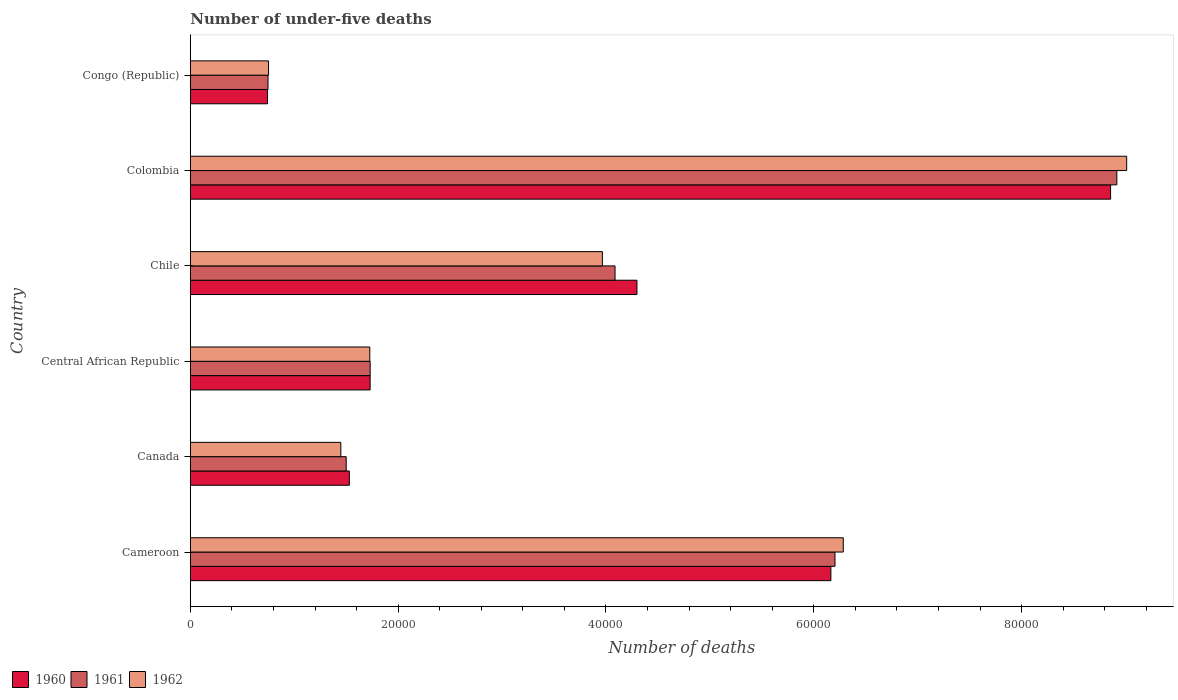How many bars are there on the 5th tick from the top?
Keep it short and to the point. 3. How many bars are there on the 3rd tick from the bottom?
Keep it short and to the point. 3. What is the label of the 4th group of bars from the top?
Ensure brevity in your answer.  Central African Republic. What is the number of under-five deaths in 1962 in Congo (Republic)?
Your response must be concise. 7530. Across all countries, what is the maximum number of under-five deaths in 1962?
Your answer should be compact. 9.01e+04. Across all countries, what is the minimum number of under-five deaths in 1961?
Give a very brief answer. 7480. In which country was the number of under-five deaths in 1960 minimum?
Ensure brevity in your answer.  Congo (Republic). What is the total number of under-five deaths in 1961 in the graph?
Your response must be concise. 2.32e+05. What is the difference between the number of under-five deaths in 1962 in Canada and that in Chile?
Offer a very short reply. -2.52e+04. What is the difference between the number of under-five deaths in 1961 in Congo (Republic) and the number of under-five deaths in 1962 in Chile?
Keep it short and to the point. -3.22e+04. What is the average number of under-five deaths in 1960 per country?
Keep it short and to the point. 3.89e+04. In how many countries, is the number of under-five deaths in 1961 greater than 40000 ?
Keep it short and to the point. 3. What is the ratio of the number of under-five deaths in 1960 in Canada to that in Central African Republic?
Provide a succinct answer. 0.88. Is the number of under-five deaths in 1960 in Central African Republic less than that in Colombia?
Your response must be concise. Yes. What is the difference between the highest and the second highest number of under-five deaths in 1962?
Your answer should be compact. 2.73e+04. What is the difference between the highest and the lowest number of under-five deaths in 1960?
Keep it short and to the point. 8.11e+04. In how many countries, is the number of under-five deaths in 1962 greater than the average number of under-five deaths in 1962 taken over all countries?
Make the answer very short. 3. What does the 2nd bar from the top in Canada represents?
Give a very brief answer. 1961. What does the 1st bar from the bottom in Cameroon represents?
Provide a short and direct response. 1960. Are all the bars in the graph horizontal?
Your answer should be very brief. Yes. How many countries are there in the graph?
Keep it short and to the point. 6. What is the difference between two consecutive major ticks on the X-axis?
Your answer should be compact. 2.00e+04. Are the values on the major ticks of X-axis written in scientific E-notation?
Offer a terse response. No. Does the graph contain any zero values?
Offer a very short reply. No. Where does the legend appear in the graph?
Provide a succinct answer. Bottom left. What is the title of the graph?
Provide a succinct answer. Number of under-five deaths. Does "1991" appear as one of the legend labels in the graph?
Offer a very short reply. No. What is the label or title of the X-axis?
Provide a succinct answer. Number of deaths. What is the label or title of the Y-axis?
Ensure brevity in your answer.  Country. What is the Number of deaths in 1960 in Cameroon?
Make the answer very short. 6.16e+04. What is the Number of deaths of 1961 in Cameroon?
Offer a terse response. 6.20e+04. What is the Number of deaths of 1962 in Cameroon?
Your response must be concise. 6.28e+04. What is the Number of deaths in 1960 in Canada?
Make the answer very short. 1.53e+04. What is the Number of deaths of 1961 in Canada?
Give a very brief answer. 1.50e+04. What is the Number of deaths in 1962 in Canada?
Your answer should be very brief. 1.45e+04. What is the Number of deaths in 1960 in Central African Republic?
Provide a short and direct response. 1.73e+04. What is the Number of deaths of 1961 in Central African Republic?
Offer a terse response. 1.73e+04. What is the Number of deaths in 1962 in Central African Republic?
Your answer should be compact. 1.73e+04. What is the Number of deaths of 1960 in Chile?
Give a very brief answer. 4.30e+04. What is the Number of deaths of 1961 in Chile?
Offer a terse response. 4.09e+04. What is the Number of deaths in 1962 in Chile?
Provide a short and direct response. 3.97e+04. What is the Number of deaths in 1960 in Colombia?
Offer a terse response. 8.86e+04. What is the Number of deaths in 1961 in Colombia?
Make the answer very short. 8.92e+04. What is the Number of deaths of 1962 in Colombia?
Offer a terse response. 9.01e+04. What is the Number of deaths of 1960 in Congo (Republic)?
Your answer should be very brief. 7431. What is the Number of deaths of 1961 in Congo (Republic)?
Offer a very short reply. 7480. What is the Number of deaths of 1962 in Congo (Republic)?
Keep it short and to the point. 7530. Across all countries, what is the maximum Number of deaths in 1960?
Provide a short and direct response. 8.86e+04. Across all countries, what is the maximum Number of deaths in 1961?
Make the answer very short. 8.92e+04. Across all countries, what is the maximum Number of deaths of 1962?
Your answer should be compact. 9.01e+04. Across all countries, what is the minimum Number of deaths in 1960?
Offer a terse response. 7431. Across all countries, what is the minimum Number of deaths in 1961?
Your response must be concise. 7480. Across all countries, what is the minimum Number of deaths of 1962?
Your answer should be compact. 7530. What is the total Number of deaths in 1960 in the graph?
Give a very brief answer. 2.33e+05. What is the total Number of deaths of 1961 in the graph?
Provide a short and direct response. 2.32e+05. What is the total Number of deaths in 1962 in the graph?
Make the answer very short. 2.32e+05. What is the difference between the Number of deaths in 1960 in Cameroon and that in Canada?
Offer a terse response. 4.63e+04. What is the difference between the Number of deaths in 1961 in Cameroon and that in Canada?
Your response must be concise. 4.70e+04. What is the difference between the Number of deaths in 1962 in Cameroon and that in Canada?
Your answer should be compact. 4.83e+04. What is the difference between the Number of deaths in 1960 in Cameroon and that in Central African Republic?
Offer a terse response. 4.43e+04. What is the difference between the Number of deaths of 1961 in Cameroon and that in Central African Republic?
Provide a succinct answer. 4.47e+04. What is the difference between the Number of deaths in 1962 in Cameroon and that in Central African Republic?
Your answer should be very brief. 4.56e+04. What is the difference between the Number of deaths in 1960 in Cameroon and that in Chile?
Your response must be concise. 1.87e+04. What is the difference between the Number of deaths of 1961 in Cameroon and that in Chile?
Your answer should be compact. 2.12e+04. What is the difference between the Number of deaths of 1962 in Cameroon and that in Chile?
Your answer should be very brief. 2.32e+04. What is the difference between the Number of deaths in 1960 in Cameroon and that in Colombia?
Your response must be concise. -2.69e+04. What is the difference between the Number of deaths in 1961 in Cameroon and that in Colombia?
Give a very brief answer. -2.71e+04. What is the difference between the Number of deaths in 1962 in Cameroon and that in Colombia?
Your answer should be compact. -2.73e+04. What is the difference between the Number of deaths in 1960 in Cameroon and that in Congo (Republic)?
Provide a short and direct response. 5.42e+04. What is the difference between the Number of deaths of 1961 in Cameroon and that in Congo (Republic)?
Provide a succinct answer. 5.46e+04. What is the difference between the Number of deaths of 1962 in Cameroon and that in Congo (Republic)?
Give a very brief answer. 5.53e+04. What is the difference between the Number of deaths in 1960 in Canada and that in Central African Republic?
Your response must be concise. -2000. What is the difference between the Number of deaths of 1961 in Canada and that in Central African Republic?
Provide a short and direct response. -2304. What is the difference between the Number of deaths in 1962 in Canada and that in Central African Republic?
Give a very brief answer. -2788. What is the difference between the Number of deaths in 1960 in Canada and that in Chile?
Offer a terse response. -2.77e+04. What is the difference between the Number of deaths of 1961 in Canada and that in Chile?
Provide a succinct answer. -2.59e+04. What is the difference between the Number of deaths in 1962 in Canada and that in Chile?
Offer a very short reply. -2.52e+04. What is the difference between the Number of deaths in 1960 in Canada and that in Colombia?
Offer a very short reply. -7.33e+04. What is the difference between the Number of deaths in 1961 in Canada and that in Colombia?
Your answer should be very brief. -7.42e+04. What is the difference between the Number of deaths in 1962 in Canada and that in Colombia?
Ensure brevity in your answer.  -7.56e+04. What is the difference between the Number of deaths in 1960 in Canada and that in Congo (Republic)?
Offer a terse response. 7874. What is the difference between the Number of deaths of 1961 in Canada and that in Congo (Republic)?
Your response must be concise. 7522. What is the difference between the Number of deaths in 1962 in Canada and that in Congo (Republic)?
Offer a very short reply. 6955. What is the difference between the Number of deaths of 1960 in Central African Republic and that in Chile?
Your answer should be very brief. -2.57e+04. What is the difference between the Number of deaths of 1961 in Central African Republic and that in Chile?
Keep it short and to the point. -2.36e+04. What is the difference between the Number of deaths in 1962 in Central African Republic and that in Chile?
Make the answer very short. -2.24e+04. What is the difference between the Number of deaths of 1960 in Central African Republic and that in Colombia?
Give a very brief answer. -7.13e+04. What is the difference between the Number of deaths of 1961 in Central African Republic and that in Colombia?
Keep it short and to the point. -7.18e+04. What is the difference between the Number of deaths in 1962 in Central African Republic and that in Colombia?
Your answer should be very brief. -7.28e+04. What is the difference between the Number of deaths in 1960 in Central African Republic and that in Congo (Republic)?
Provide a short and direct response. 9874. What is the difference between the Number of deaths in 1961 in Central African Republic and that in Congo (Republic)?
Keep it short and to the point. 9826. What is the difference between the Number of deaths of 1962 in Central African Republic and that in Congo (Republic)?
Offer a terse response. 9743. What is the difference between the Number of deaths in 1960 in Chile and that in Colombia?
Your answer should be very brief. -4.56e+04. What is the difference between the Number of deaths of 1961 in Chile and that in Colombia?
Keep it short and to the point. -4.83e+04. What is the difference between the Number of deaths of 1962 in Chile and that in Colombia?
Provide a succinct answer. -5.04e+04. What is the difference between the Number of deaths of 1960 in Chile and that in Congo (Republic)?
Offer a terse response. 3.55e+04. What is the difference between the Number of deaths of 1961 in Chile and that in Congo (Republic)?
Keep it short and to the point. 3.34e+04. What is the difference between the Number of deaths in 1962 in Chile and that in Congo (Republic)?
Give a very brief answer. 3.21e+04. What is the difference between the Number of deaths of 1960 in Colombia and that in Congo (Republic)?
Provide a succinct answer. 8.11e+04. What is the difference between the Number of deaths of 1961 in Colombia and that in Congo (Republic)?
Offer a terse response. 8.17e+04. What is the difference between the Number of deaths in 1962 in Colombia and that in Congo (Republic)?
Offer a very short reply. 8.26e+04. What is the difference between the Number of deaths of 1960 in Cameroon and the Number of deaths of 1961 in Canada?
Give a very brief answer. 4.66e+04. What is the difference between the Number of deaths in 1960 in Cameroon and the Number of deaths in 1962 in Canada?
Make the answer very short. 4.72e+04. What is the difference between the Number of deaths of 1961 in Cameroon and the Number of deaths of 1962 in Canada?
Ensure brevity in your answer.  4.76e+04. What is the difference between the Number of deaths in 1960 in Cameroon and the Number of deaths in 1961 in Central African Republic?
Offer a terse response. 4.43e+04. What is the difference between the Number of deaths in 1960 in Cameroon and the Number of deaths in 1962 in Central African Republic?
Your answer should be compact. 4.44e+04. What is the difference between the Number of deaths in 1961 in Cameroon and the Number of deaths in 1962 in Central African Republic?
Make the answer very short. 4.48e+04. What is the difference between the Number of deaths of 1960 in Cameroon and the Number of deaths of 1961 in Chile?
Your answer should be very brief. 2.08e+04. What is the difference between the Number of deaths in 1960 in Cameroon and the Number of deaths in 1962 in Chile?
Your answer should be compact. 2.20e+04. What is the difference between the Number of deaths in 1961 in Cameroon and the Number of deaths in 1962 in Chile?
Provide a succinct answer. 2.24e+04. What is the difference between the Number of deaths of 1960 in Cameroon and the Number of deaths of 1961 in Colombia?
Your response must be concise. -2.75e+04. What is the difference between the Number of deaths in 1960 in Cameroon and the Number of deaths in 1962 in Colombia?
Give a very brief answer. -2.85e+04. What is the difference between the Number of deaths of 1961 in Cameroon and the Number of deaths of 1962 in Colombia?
Give a very brief answer. -2.81e+04. What is the difference between the Number of deaths in 1960 in Cameroon and the Number of deaths in 1961 in Congo (Republic)?
Your answer should be very brief. 5.42e+04. What is the difference between the Number of deaths in 1960 in Cameroon and the Number of deaths in 1962 in Congo (Republic)?
Make the answer very short. 5.41e+04. What is the difference between the Number of deaths in 1961 in Cameroon and the Number of deaths in 1962 in Congo (Republic)?
Your answer should be very brief. 5.45e+04. What is the difference between the Number of deaths of 1960 in Canada and the Number of deaths of 1961 in Central African Republic?
Your answer should be compact. -2001. What is the difference between the Number of deaths of 1960 in Canada and the Number of deaths of 1962 in Central African Republic?
Your answer should be compact. -1968. What is the difference between the Number of deaths of 1961 in Canada and the Number of deaths of 1962 in Central African Republic?
Offer a very short reply. -2271. What is the difference between the Number of deaths in 1960 in Canada and the Number of deaths in 1961 in Chile?
Give a very brief answer. -2.56e+04. What is the difference between the Number of deaths of 1960 in Canada and the Number of deaths of 1962 in Chile?
Keep it short and to the point. -2.44e+04. What is the difference between the Number of deaths of 1961 in Canada and the Number of deaths of 1962 in Chile?
Make the answer very short. -2.47e+04. What is the difference between the Number of deaths of 1960 in Canada and the Number of deaths of 1961 in Colombia?
Ensure brevity in your answer.  -7.39e+04. What is the difference between the Number of deaths of 1960 in Canada and the Number of deaths of 1962 in Colombia?
Make the answer very short. -7.48e+04. What is the difference between the Number of deaths in 1961 in Canada and the Number of deaths in 1962 in Colombia?
Your response must be concise. -7.51e+04. What is the difference between the Number of deaths of 1960 in Canada and the Number of deaths of 1961 in Congo (Republic)?
Provide a succinct answer. 7825. What is the difference between the Number of deaths of 1960 in Canada and the Number of deaths of 1962 in Congo (Republic)?
Offer a terse response. 7775. What is the difference between the Number of deaths of 1961 in Canada and the Number of deaths of 1962 in Congo (Republic)?
Keep it short and to the point. 7472. What is the difference between the Number of deaths of 1960 in Central African Republic and the Number of deaths of 1961 in Chile?
Keep it short and to the point. -2.36e+04. What is the difference between the Number of deaths of 1960 in Central African Republic and the Number of deaths of 1962 in Chile?
Ensure brevity in your answer.  -2.24e+04. What is the difference between the Number of deaths of 1961 in Central African Republic and the Number of deaths of 1962 in Chile?
Provide a short and direct response. -2.23e+04. What is the difference between the Number of deaths in 1960 in Central African Republic and the Number of deaths in 1961 in Colombia?
Keep it short and to the point. -7.19e+04. What is the difference between the Number of deaths in 1960 in Central African Republic and the Number of deaths in 1962 in Colombia?
Your response must be concise. -7.28e+04. What is the difference between the Number of deaths of 1961 in Central African Republic and the Number of deaths of 1962 in Colombia?
Offer a terse response. -7.28e+04. What is the difference between the Number of deaths of 1960 in Central African Republic and the Number of deaths of 1961 in Congo (Republic)?
Offer a very short reply. 9825. What is the difference between the Number of deaths of 1960 in Central African Republic and the Number of deaths of 1962 in Congo (Republic)?
Offer a very short reply. 9775. What is the difference between the Number of deaths in 1961 in Central African Republic and the Number of deaths in 1962 in Congo (Republic)?
Your answer should be very brief. 9776. What is the difference between the Number of deaths in 1960 in Chile and the Number of deaths in 1961 in Colombia?
Your answer should be compact. -4.62e+04. What is the difference between the Number of deaths in 1960 in Chile and the Number of deaths in 1962 in Colombia?
Offer a terse response. -4.71e+04. What is the difference between the Number of deaths of 1961 in Chile and the Number of deaths of 1962 in Colombia?
Provide a short and direct response. -4.92e+04. What is the difference between the Number of deaths in 1960 in Chile and the Number of deaths in 1961 in Congo (Republic)?
Your response must be concise. 3.55e+04. What is the difference between the Number of deaths of 1960 in Chile and the Number of deaths of 1962 in Congo (Republic)?
Provide a short and direct response. 3.54e+04. What is the difference between the Number of deaths in 1961 in Chile and the Number of deaths in 1962 in Congo (Republic)?
Offer a terse response. 3.33e+04. What is the difference between the Number of deaths of 1960 in Colombia and the Number of deaths of 1961 in Congo (Republic)?
Give a very brief answer. 8.11e+04. What is the difference between the Number of deaths in 1960 in Colombia and the Number of deaths in 1962 in Congo (Republic)?
Your response must be concise. 8.10e+04. What is the difference between the Number of deaths of 1961 in Colombia and the Number of deaths of 1962 in Congo (Republic)?
Ensure brevity in your answer.  8.16e+04. What is the average Number of deaths of 1960 per country?
Keep it short and to the point. 3.89e+04. What is the average Number of deaths of 1961 per country?
Your answer should be very brief. 3.86e+04. What is the average Number of deaths in 1962 per country?
Make the answer very short. 3.86e+04. What is the difference between the Number of deaths of 1960 and Number of deaths of 1961 in Cameroon?
Provide a short and direct response. -396. What is the difference between the Number of deaths of 1960 and Number of deaths of 1962 in Cameroon?
Make the answer very short. -1194. What is the difference between the Number of deaths in 1961 and Number of deaths in 1962 in Cameroon?
Your answer should be compact. -798. What is the difference between the Number of deaths in 1960 and Number of deaths in 1961 in Canada?
Offer a very short reply. 303. What is the difference between the Number of deaths of 1960 and Number of deaths of 1962 in Canada?
Provide a succinct answer. 820. What is the difference between the Number of deaths of 1961 and Number of deaths of 1962 in Canada?
Provide a succinct answer. 517. What is the difference between the Number of deaths in 1960 and Number of deaths in 1962 in Central African Republic?
Ensure brevity in your answer.  32. What is the difference between the Number of deaths in 1960 and Number of deaths in 1961 in Chile?
Give a very brief answer. 2108. What is the difference between the Number of deaths of 1960 and Number of deaths of 1962 in Chile?
Keep it short and to the point. 3325. What is the difference between the Number of deaths in 1961 and Number of deaths in 1962 in Chile?
Make the answer very short. 1217. What is the difference between the Number of deaths in 1960 and Number of deaths in 1961 in Colombia?
Ensure brevity in your answer.  -600. What is the difference between the Number of deaths of 1960 and Number of deaths of 1962 in Colombia?
Your answer should be compact. -1548. What is the difference between the Number of deaths in 1961 and Number of deaths in 1962 in Colombia?
Give a very brief answer. -948. What is the difference between the Number of deaths in 1960 and Number of deaths in 1961 in Congo (Republic)?
Keep it short and to the point. -49. What is the difference between the Number of deaths in 1960 and Number of deaths in 1962 in Congo (Republic)?
Offer a terse response. -99. What is the difference between the Number of deaths in 1961 and Number of deaths in 1962 in Congo (Republic)?
Provide a succinct answer. -50. What is the ratio of the Number of deaths of 1960 in Cameroon to that in Canada?
Offer a terse response. 4.03. What is the ratio of the Number of deaths of 1961 in Cameroon to that in Canada?
Ensure brevity in your answer.  4.14. What is the ratio of the Number of deaths of 1962 in Cameroon to that in Canada?
Provide a succinct answer. 4.34. What is the ratio of the Number of deaths in 1960 in Cameroon to that in Central African Republic?
Provide a short and direct response. 3.56. What is the ratio of the Number of deaths of 1961 in Cameroon to that in Central African Republic?
Give a very brief answer. 3.58. What is the ratio of the Number of deaths of 1962 in Cameroon to that in Central African Republic?
Offer a very short reply. 3.64. What is the ratio of the Number of deaths of 1960 in Cameroon to that in Chile?
Keep it short and to the point. 1.43. What is the ratio of the Number of deaths of 1961 in Cameroon to that in Chile?
Ensure brevity in your answer.  1.52. What is the ratio of the Number of deaths in 1962 in Cameroon to that in Chile?
Offer a terse response. 1.58. What is the ratio of the Number of deaths of 1960 in Cameroon to that in Colombia?
Offer a very short reply. 0.7. What is the ratio of the Number of deaths of 1961 in Cameroon to that in Colombia?
Offer a very short reply. 0.7. What is the ratio of the Number of deaths in 1962 in Cameroon to that in Colombia?
Provide a succinct answer. 0.7. What is the ratio of the Number of deaths of 1960 in Cameroon to that in Congo (Republic)?
Your response must be concise. 8.29. What is the ratio of the Number of deaths in 1961 in Cameroon to that in Congo (Republic)?
Your answer should be compact. 8.29. What is the ratio of the Number of deaths in 1962 in Cameroon to that in Congo (Republic)?
Offer a very short reply. 8.34. What is the ratio of the Number of deaths of 1960 in Canada to that in Central African Republic?
Your response must be concise. 0.88. What is the ratio of the Number of deaths in 1961 in Canada to that in Central African Republic?
Make the answer very short. 0.87. What is the ratio of the Number of deaths of 1962 in Canada to that in Central African Republic?
Offer a very short reply. 0.84. What is the ratio of the Number of deaths of 1960 in Canada to that in Chile?
Make the answer very short. 0.36. What is the ratio of the Number of deaths of 1961 in Canada to that in Chile?
Your answer should be very brief. 0.37. What is the ratio of the Number of deaths of 1962 in Canada to that in Chile?
Keep it short and to the point. 0.37. What is the ratio of the Number of deaths of 1960 in Canada to that in Colombia?
Your response must be concise. 0.17. What is the ratio of the Number of deaths of 1961 in Canada to that in Colombia?
Offer a very short reply. 0.17. What is the ratio of the Number of deaths in 1962 in Canada to that in Colombia?
Provide a succinct answer. 0.16. What is the ratio of the Number of deaths of 1960 in Canada to that in Congo (Republic)?
Offer a very short reply. 2.06. What is the ratio of the Number of deaths in 1961 in Canada to that in Congo (Republic)?
Offer a terse response. 2.01. What is the ratio of the Number of deaths of 1962 in Canada to that in Congo (Republic)?
Your answer should be compact. 1.92. What is the ratio of the Number of deaths in 1960 in Central African Republic to that in Chile?
Your response must be concise. 0.4. What is the ratio of the Number of deaths of 1961 in Central African Republic to that in Chile?
Offer a very short reply. 0.42. What is the ratio of the Number of deaths in 1962 in Central African Republic to that in Chile?
Provide a short and direct response. 0.44. What is the ratio of the Number of deaths of 1960 in Central African Republic to that in Colombia?
Your response must be concise. 0.2. What is the ratio of the Number of deaths in 1961 in Central African Republic to that in Colombia?
Your response must be concise. 0.19. What is the ratio of the Number of deaths of 1962 in Central African Republic to that in Colombia?
Provide a succinct answer. 0.19. What is the ratio of the Number of deaths of 1960 in Central African Republic to that in Congo (Republic)?
Offer a terse response. 2.33. What is the ratio of the Number of deaths of 1961 in Central African Republic to that in Congo (Republic)?
Keep it short and to the point. 2.31. What is the ratio of the Number of deaths in 1962 in Central African Republic to that in Congo (Republic)?
Ensure brevity in your answer.  2.29. What is the ratio of the Number of deaths in 1960 in Chile to that in Colombia?
Your answer should be very brief. 0.49. What is the ratio of the Number of deaths in 1961 in Chile to that in Colombia?
Your answer should be very brief. 0.46. What is the ratio of the Number of deaths in 1962 in Chile to that in Colombia?
Your answer should be very brief. 0.44. What is the ratio of the Number of deaths in 1960 in Chile to that in Congo (Republic)?
Give a very brief answer. 5.78. What is the ratio of the Number of deaths of 1961 in Chile to that in Congo (Republic)?
Keep it short and to the point. 5.46. What is the ratio of the Number of deaths of 1962 in Chile to that in Congo (Republic)?
Give a very brief answer. 5.27. What is the ratio of the Number of deaths of 1960 in Colombia to that in Congo (Republic)?
Give a very brief answer. 11.92. What is the ratio of the Number of deaths of 1961 in Colombia to that in Congo (Republic)?
Ensure brevity in your answer.  11.92. What is the ratio of the Number of deaths in 1962 in Colombia to that in Congo (Republic)?
Your answer should be very brief. 11.97. What is the difference between the highest and the second highest Number of deaths in 1960?
Make the answer very short. 2.69e+04. What is the difference between the highest and the second highest Number of deaths in 1961?
Offer a very short reply. 2.71e+04. What is the difference between the highest and the second highest Number of deaths of 1962?
Your answer should be very brief. 2.73e+04. What is the difference between the highest and the lowest Number of deaths in 1960?
Ensure brevity in your answer.  8.11e+04. What is the difference between the highest and the lowest Number of deaths in 1961?
Give a very brief answer. 8.17e+04. What is the difference between the highest and the lowest Number of deaths of 1962?
Keep it short and to the point. 8.26e+04. 